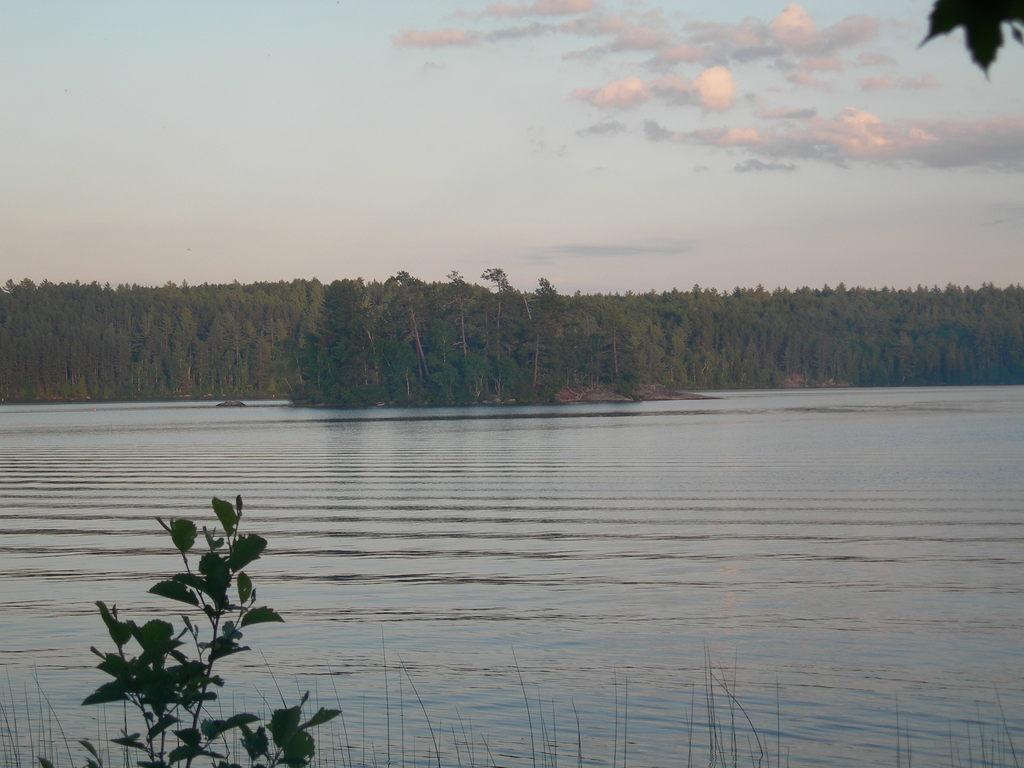Could you give a brief overview of what you see in this image? In this picture there is water at the bottom side of the image and there are trees in the center of the image, there is sky at the top side of the image and there is a plant at the bottom side of the image. 